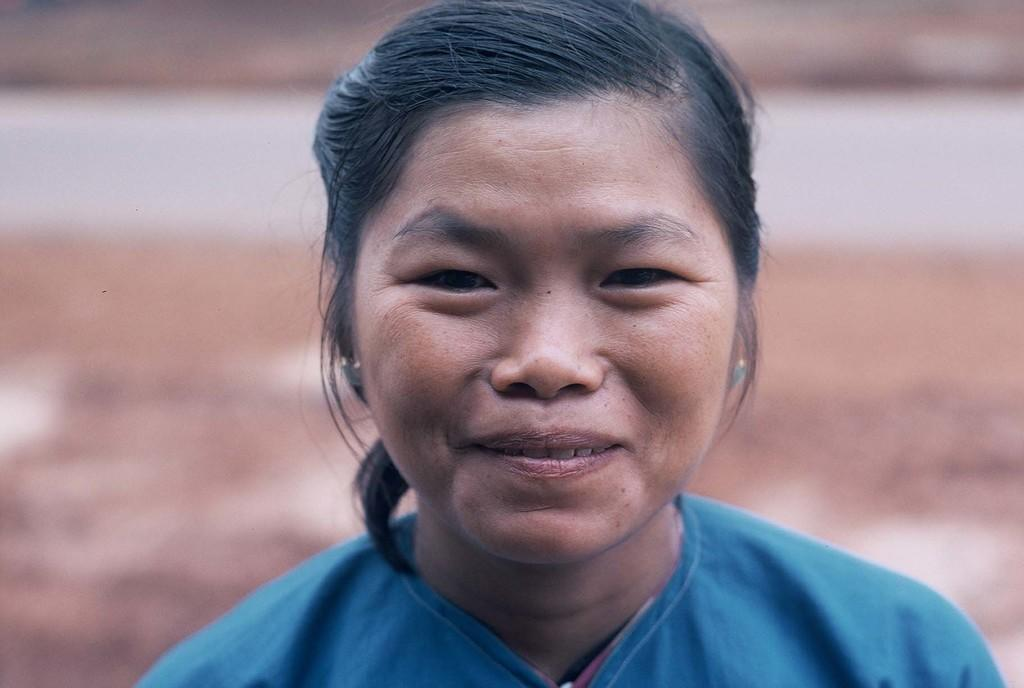Who is the main subject in the image? There is a lady in the center of the image. What is the lady wearing? The lady is wearing a blue dress. What expression does the lady have? The lady is smiling. Where is the lady's basket located in the image? There is no basket present in the image. What type of desk can be seen behind the lady in the image? There is no desk visible in the image; it only features the lady in the center. 